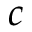Convert formula to latex. <formula><loc_0><loc_0><loc_500><loc_500>c</formula> 